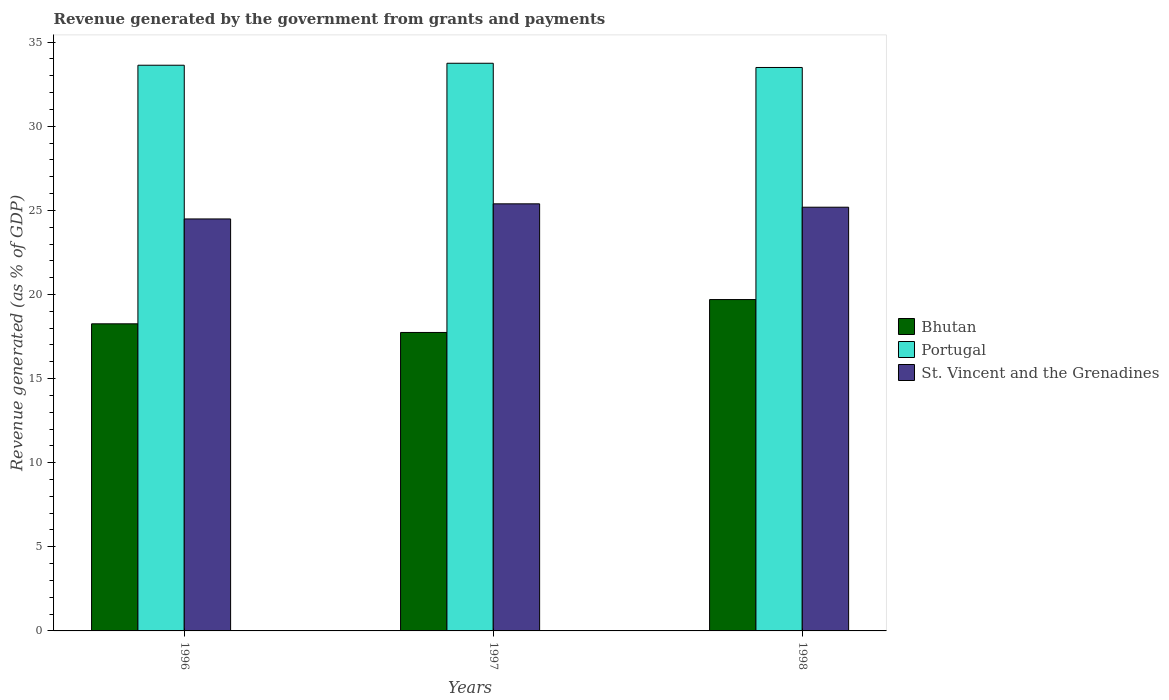How many different coloured bars are there?
Offer a terse response. 3. Are the number of bars per tick equal to the number of legend labels?
Offer a terse response. Yes. Are the number of bars on each tick of the X-axis equal?
Your answer should be compact. Yes. What is the label of the 3rd group of bars from the left?
Ensure brevity in your answer.  1998. In how many cases, is the number of bars for a given year not equal to the number of legend labels?
Offer a terse response. 0. What is the revenue generated by the government in Bhutan in 1997?
Offer a very short reply. 17.74. Across all years, what is the maximum revenue generated by the government in St. Vincent and the Grenadines?
Offer a very short reply. 25.39. Across all years, what is the minimum revenue generated by the government in Bhutan?
Your answer should be compact. 17.74. In which year was the revenue generated by the government in St. Vincent and the Grenadines minimum?
Your response must be concise. 1996. What is the total revenue generated by the government in Bhutan in the graph?
Offer a terse response. 55.7. What is the difference between the revenue generated by the government in Bhutan in 1996 and that in 1998?
Keep it short and to the point. -1.44. What is the difference between the revenue generated by the government in Portugal in 1997 and the revenue generated by the government in St. Vincent and the Grenadines in 1996?
Provide a short and direct response. 9.26. What is the average revenue generated by the government in Portugal per year?
Keep it short and to the point. 33.62. In the year 1996, what is the difference between the revenue generated by the government in Bhutan and revenue generated by the government in Portugal?
Offer a terse response. -15.37. What is the ratio of the revenue generated by the government in St. Vincent and the Grenadines in 1997 to that in 1998?
Keep it short and to the point. 1.01. Is the revenue generated by the government in Bhutan in 1997 less than that in 1998?
Make the answer very short. Yes. What is the difference between the highest and the second highest revenue generated by the government in St. Vincent and the Grenadines?
Give a very brief answer. 0.2. What is the difference between the highest and the lowest revenue generated by the government in Portugal?
Your answer should be compact. 0.25. In how many years, is the revenue generated by the government in St. Vincent and the Grenadines greater than the average revenue generated by the government in St. Vincent and the Grenadines taken over all years?
Keep it short and to the point. 2. Is the sum of the revenue generated by the government in St. Vincent and the Grenadines in 1997 and 1998 greater than the maximum revenue generated by the government in Bhutan across all years?
Your answer should be very brief. Yes. What does the 1st bar from the right in 1998 represents?
Offer a very short reply. St. Vincent and the Grenadines. How many years are there in the graph?
Your answer should be compact. 3. Where does the legend appear in the graph?
Offer a very short reply. Center right. How are the legend labels stacked?
Make the answer very short. Vertical. What is the title of the graph?
Your answer should be very brief. Revenue generated by the government from grants and payments. Does "Poland" appear as one of the legend labels in the graph?
Keep it short and to the point. No. What is the label or title of the Y-axis?
Make the answer very short. Revenue generated (as % of GDP). What is the Revenue generated (as % of GDP) of Bhutan in 1996?
Offer a terse response. 18.26. What is the Revenue generated (as % of GDP) in Portugal in 1996?
Provide a short and direct response. 33.63. What is the Revenue generated (as % of GDP) of St. Vincent and the Grenadines in 1996?
Offer a terse response. 24.49. What is the Revenue generated (as % of GDP) in Bhutan in 1997?
Keep it short and to the point. 17.74. What is the Revenue generated (as % of GDP) in Portugal in 1997?
Your answer should be very brief. 33.75. What is the Revenue generated (as % of GDP) of St. Vincent and the Grenadines in 1997?
Make the answer very short. 25.39. What is the Revenue generated (as % of GDP) of Bhutan in 1998?
Provide a short and direct response. 19.7. What is the Revenue generated (as % of GDP) of Portugal in 1998?
Your answer should be compact. 33.5. What is the Revenue generated (as % of GDP) of St. Vincent and the Grenadines in 1998?
Offer a terse response. 25.19. Across all years, what is the maximum Revenue generated (as % of GDP) in Bhutan?
Offer a very short reply. 19.7. Across all years, what is the maximum Revenue generated (as % of GDP) in Portugal?
Offer a terse response. 33.75. Across all years, what is the maximum Revenue generated (as % of GDP) of St. Vincent and the Grenadines?
Your answer should be very brief. 25.39. Across all years, what is the minimum Revenue generated (as % of GDP) of Bhutan?
Your answer should be very brief. 17.74. Across all years, what is the minimum Revenue generated (as % of GDP) in Portugal?
Ensure brevity in your answer.  33.5. Across all years, what is the minimum Revenue generated (as % of GDP) in St. Vincent and the Grenadines?
Keep it short and to the point. 24.49. What is the total Revenue generated (as % of GDP) in Bhutan in the graph?
Provide a succinct answer. 55.7. What is the total Revenue generated (as % of GDP) of Portugal in the graph?
Offer a terse response. 100.87. What is the total Revenue generated (as % of GDP) of St. Vincent and the Grenadines in the graph?
Ensure brevity in your answer.  75.07. What is the difference between the Revenue generated (as % of GDP) of Bhutan in 1996 and that in 1997?
Offer a very short reply. 0.51. What is the difference between the Revenue generated (as % of GDP) of Portugal in 1996 and that in 1997?
Give a very brief answer. -0.12. What is the difference between the Revenue generated (as % of GDP) in St. Vincent and the Grenadines in 1996 and that in 1997?
Make the answer very short. -0.9. What is the difference between the Revenue generated (as % of GDP) in Bhutan in 1996 and that in 1998?
Offer a terse response. -1.44. What is the difference between the Revenue generated (as % of GDP) of Portugal in 1996 and that in 1998?
Offer a terse response. 0.13. What is the difference between the Revenue generated (as % of GDP) of St. Vincent and the Grenadines in 1996 and that in 1998?
Your answer should be compact. -0.7. What is the difference between the Revenue generated (as % of GDP) of Bhutan in 1997 and that in 1998?
Provide a short and direct response. -1.96. What is the difference between the Revenue generated (as % of GDP) of Portugal in 1997 and that in 1998?
Provide a succinct answer. 0.25. What is the difference between the Revenue generated (as % of GDP) in St. Vincent and the Grenadines in 1997 and that in 1998?
Give a very brief answer. 0.2. What is the difference between the Revenue generated (as % of GDP) of Bhutan in 1996 and the Revenue generated (as % of GDP) of Portugal in 1997?
Your answer should be compact. -15.49. What is the difference between the Revenue generated (as % of GDP) of Bhutan in 1996 and the Revenue generated (as % of GDP) of St. Vincent and the Grenadines in 1997?
Your answer should be very brief. -7.13. What is the difference between the Revenue generated (as % of GDP) of Portugal in 1996 and the Revenue generated (as % of GDP) of St. Vincent and the Grenadines in 1997?
Ensure brevity in your answer.  8.24. What is the difference between the Revenue generated (as % of GDP) in Bhutan in 1996 and the Revenue generated (as % of GDP) in Portugal in 1998?
Your answer should be very brief. -15.24. What is the difference between the Revenue generated (as % of GDP) in Bhutan in 1996 and the Revenue generated (as % of GDP) in St. Vincent and the Grenadines in 1998?
Provide a succinct answer. -6.93. What is the difference between the Revenue generated (as % of GDP) in Portugal in 1996 and the Revenue generated (as % of GDP) in St. Vincent and the Grenadines in 1998?
Your response must be concise. 8.44. What is the difference between the Revenue generated (as % of GDP) in Bhutan in 1997 and the Revenue generated (as % of GDP) in Portugal in 1998?
Give a very brief answer. -15.75. What is the difference between the Revenue generated (as % of GDP) in Bhutan in 1997 and the Revenue generated (as % of GDP) in St. Vincent and the Grenadines in 1998?
Your answer should be very brief. -7.45. What is the difference between the Revenue generated (as % of GDP) of Portugal in 1997 and the Revenue generated (as % of GDP) of St. Vincent and the Grenadines in 1998?
Offer a very short reply. 8.56. What is the average Revenue generated (as % of GDP) of Bhutan per year?
Offer a very short reply. 18.57. What is the average Revenue generated (as % of GDP) of Portugal per year?
Ensure brevity in your answer.  33.62. What is the average Revenue generated (as % of GDP) of St. Vincent and the Grenadines per year?
Offer a very short reply. 25.02. In the year 1996, what is the difference between the Revenue generated (as % of GDP) in Bhutan and Revenue generated (as % of GDP) in Portugal?
Your answer should be very brief. -15.37. In the year 1996, what is the difference between the Revenue generated (as % of GDP) in Bhutan and Revenue generated (as % of GDP) in St. Vincent and the Grenadines?
Offer a terse response. -6.23. In the year 1996, what is the difference between the Revenue generated (as % of GDP) in Portugal and Revenue generated (as % of GDP) in St. Vincent and the Grenadines?
Your response must be concise. 9.14. In the year 1997, what is the difference between the Revenue generated (as % of GDP) in Bhutan and Revenue generated (as % of GDP) in Portugal?
Your response must be concise. -16. In the year 1997, what is the difference between the Revenue generated (as % of GDP) of Bhutan and Revenue generated (as % of GDP) of St. Vincent and the Grenadines?
Your answer should be very brief. -7.65. In the year 1997, what is the difference between the Revenue generated (as % of GDP) of Portugal and Revenue generated (as % of GDP) of St. Vincent and the Grenadines?
Offer a very short reply. 8.36. In the year 1998, what is the difference between the Revenue generated (as % of GDP) in Bhutan and Revenue generated (as % of GDP) in Portugal?
Ensure brevity in your answer.  -13.8. In the year 1998, what is the difference between the Revenue generated (as % of GDP) in Bhutan and Revenue generated (as % of GDP) in St. Vincent and the Grenadines?
Keep it short and to the point. -5.49. In the year 1998, what is the difference between the Revenue generated (as % of GDP) in Portugal and Revenue generated (as % of GDP) in St. Vincent and the Grenadines?
Ensure brevity in your answer.  8.31. What is the ratio of the Revenue generated (as % of GDP) of Bhutan in 1996 to that in 1997?
Keep it short and to the point. 1.03. What is the ratio of the Revenue generated (as % of GDP) in Portugal in 1996 to that in 1997?
Make the answer very short. 1. What is the ratio of the Revenue generated (as % of GDP) in St. Vincent and the Grenadines in 1996 to that in 1997?
Keep it short and to the point. 0.96. What is the ratio of the Revenue generated (as % of GDP) of Bhutan in 1996 to that in 1998?
Provide a succinct answer. 0.93. What is the ratio of the Revenue generated (as % of GDP) in Portugal in 1996 to that in 1998?
Offer a very short reply. 1. What is the ratio of the Revenue generated (as % of GDP) of St. Vincent and the Grenadines in 1996 to that in 1998?
Your answer should be compact. 0.97. What is the ratio of the Revenue generated (as % of GDP) of Bhutan in 1997 to that in 1998?
Your answer should be very brief. 0.9. What is the ratio of the Revenue generated (as % of GDP) in Portugal in 1997 to that in 1998?
Provide a succinct answer. 1.01. What is the difference between the highest and the second highest Revenue generated (as % of GDP) in Bhutan?
Provide a succinct answer. 1.44. What is the difference between the highest and the second highest Revenue generated (as % of GDP) in Portugal?
Keep it short and to the point. 0.12. What is the difference between the highest and the second highest Revenue generated (as % of GDP) in St. Vincent and the Grenadines?
Your answer should be very brief. 0.2. What is the difference between the highest and the lowest Revenue generated (as % of GDP) of Bhutan?
Offer a terse response. 1.96. What is the difference between the highest and the lowest Revenue generated (as % of GDP) of Portugal?
Provide a succinct answer. 0.25. What is the difference between the highest and the lowest Revenue generated (as % of GDP) in St. Vincent and the Grenadines?
Offer a terse response. 0.9. 